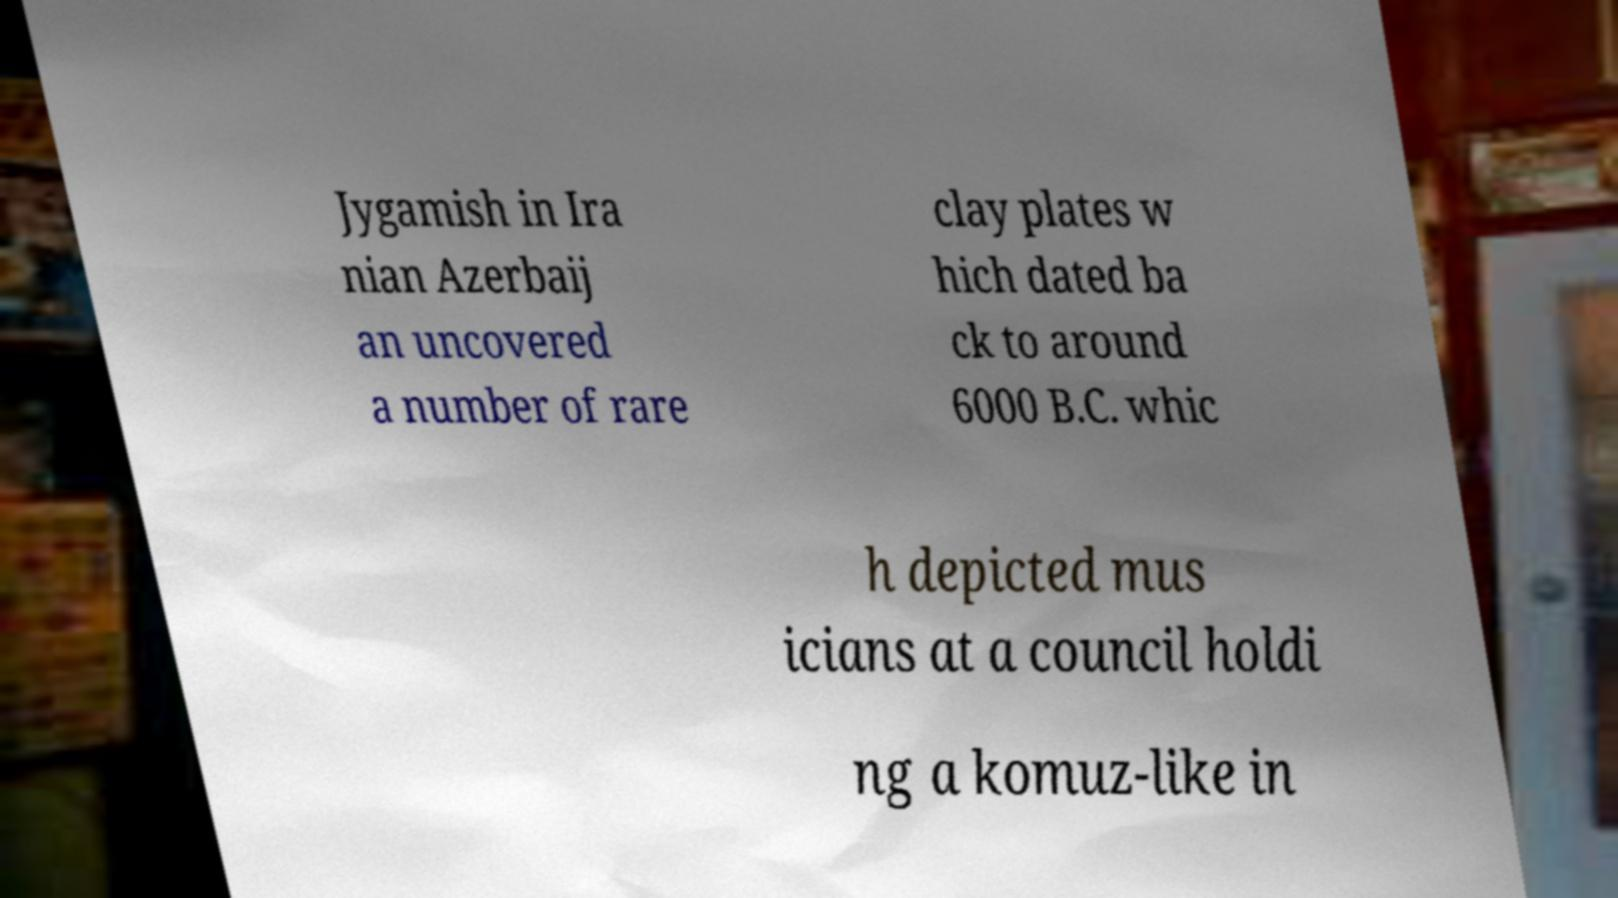Can you read and provide the text displayed in the image?This photo seems to have some interesting text. Can you extract and type it out for me? Jygamish in Ira nian Azerbaij an uncovered a number of rare clay plates w hich dated ba ck to around 6000 B.C. whic h depicted mus icians at a council holdi ng a komuz-like in 